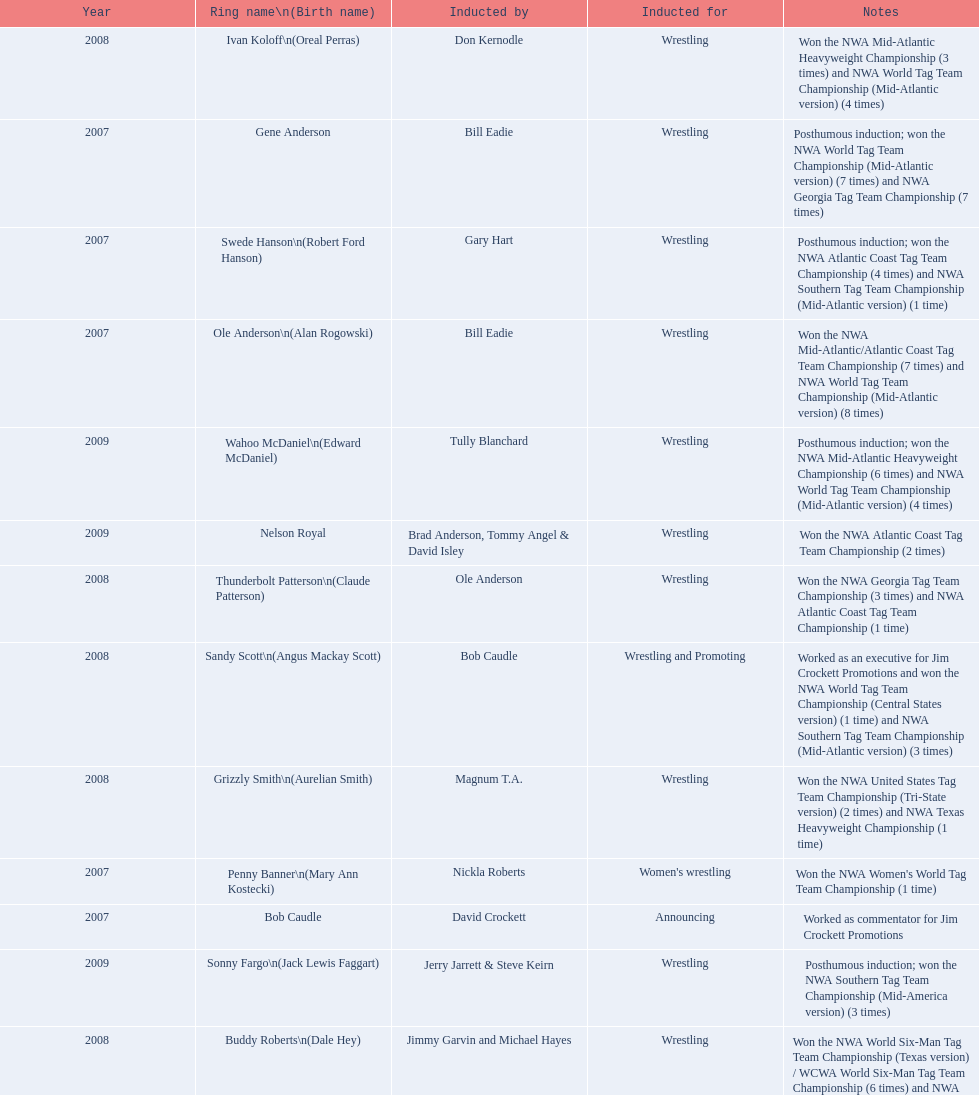What number of members were inducted before 2009? 14. 